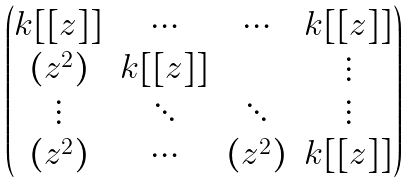Convert formula to latex. <formula><loc_0><loc_0><loc_500><loc_500>\begin{pmatrix} k [ [ z ] ] & \cdots & \cdots & k [ [ z ] ] \\ ( z ^ { 2 } ) & k [ [ z ] ] & & \vdots \\ \vdots & \ddots & \ddots & \vdots \\ ( z ^ { 2 } ) & \cdots & ( z ^ { 2 } ) & k [ [ z ] ] \end{pmatrix}</formula> 